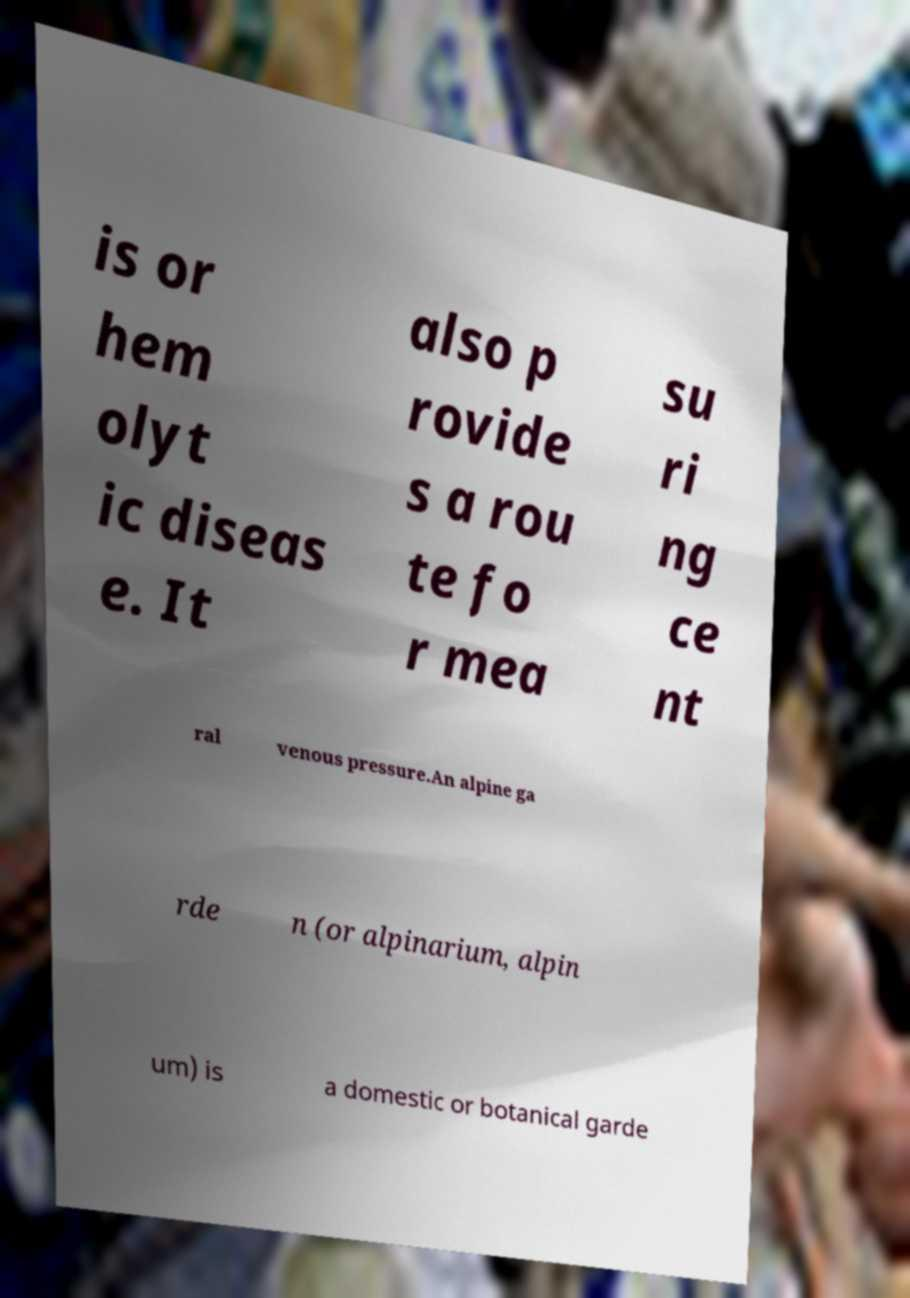For documentation purposes, I need the text within this image transcribed. Could you provide that? is or hem olyt ic diseas e. It also p rovide s a rou te fo r mea su ri ng ce nt ral venous pressure.An alpine ga rde n (or alpinarium, alpin um) is a domestic or botanical garde 